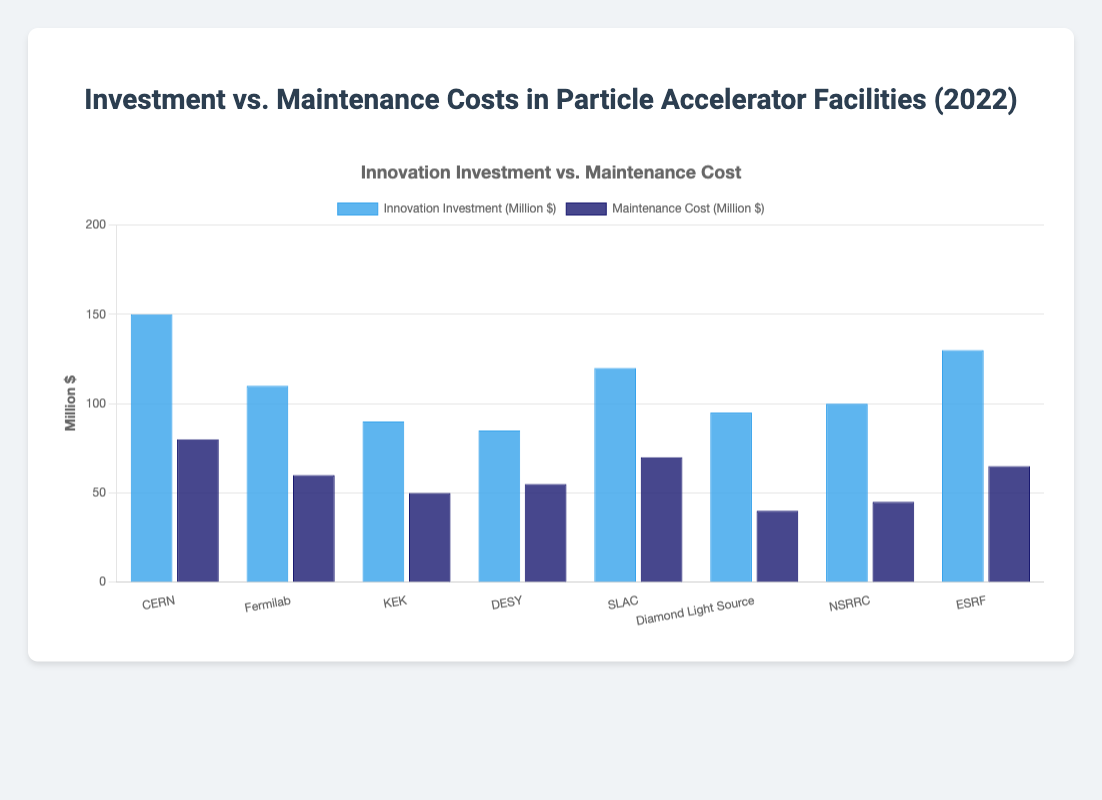Which facility had the highest innovation investment in 2022? Look at the blue bars representing innovation investments; CERN has the tallest blue bar indicating the highest investment.
Answer: CERN What is the difference between CERN's innovation investment and maintenance cost? Subtract the maintenance cost (80) from the innovation investment (150). 150 - 80 = 70
Answer: 70 million dollars Which facility has the lowest maintenance cost? Compare the heights of the dark blue bars representing maintenance costs; the shortest dark blue bar is for Diamond Light Source.
Answer: Diamond Light Source What is the total innovation investment for all facilities combined? Sum up all the innovation investments: 150 + 110 + 90 + 85 + 120 + 95 + 100 + 130. The total is 880.
Answer: 880 million dollars Which facility had nearly equal innovation investment and maintenance cost? Compare the heights of the blue and dark blue bars; DESY has the smallest difference between them.
Answer: DESY How much more did SLAC invest in innovation compared to maintenance? Subtract the maintenance cost (70) from the innovation investment (120) for SLAC. 120 - 70 = 50
Answer: 50 million dollars What is the average maintenance cost for the facilities? Sum up all the maintenance costs: 80 + 60 + 50 + 55 + 70 + 40 + 45 + 65. The total is 465. Divide by the number of facilities (8). 465 / 8 = 58.125
Answer: 58.125 million dollars Which two facilities have the closest innovation investments? Compare the heights of the blue bars; KEK (90) and DESY (85) have the closest values, differing by only 5 million dollars.
Answer: KEK and DESY What is the combined cost (innovation investment + maintenance) for Fermilab? Sum the innovation investment and maintenance cost for Fermilab: 110 (innovation) + 60 (maintenance) = 170
Answer: 170 million dollars How does the maintenance cost of NSRRC compare to the innovation investment of Diamond Light Source? The maintenance cost for NSRRC (45) is greater than Diamond Light Source's innovation investment (40).
Answer: Greater 